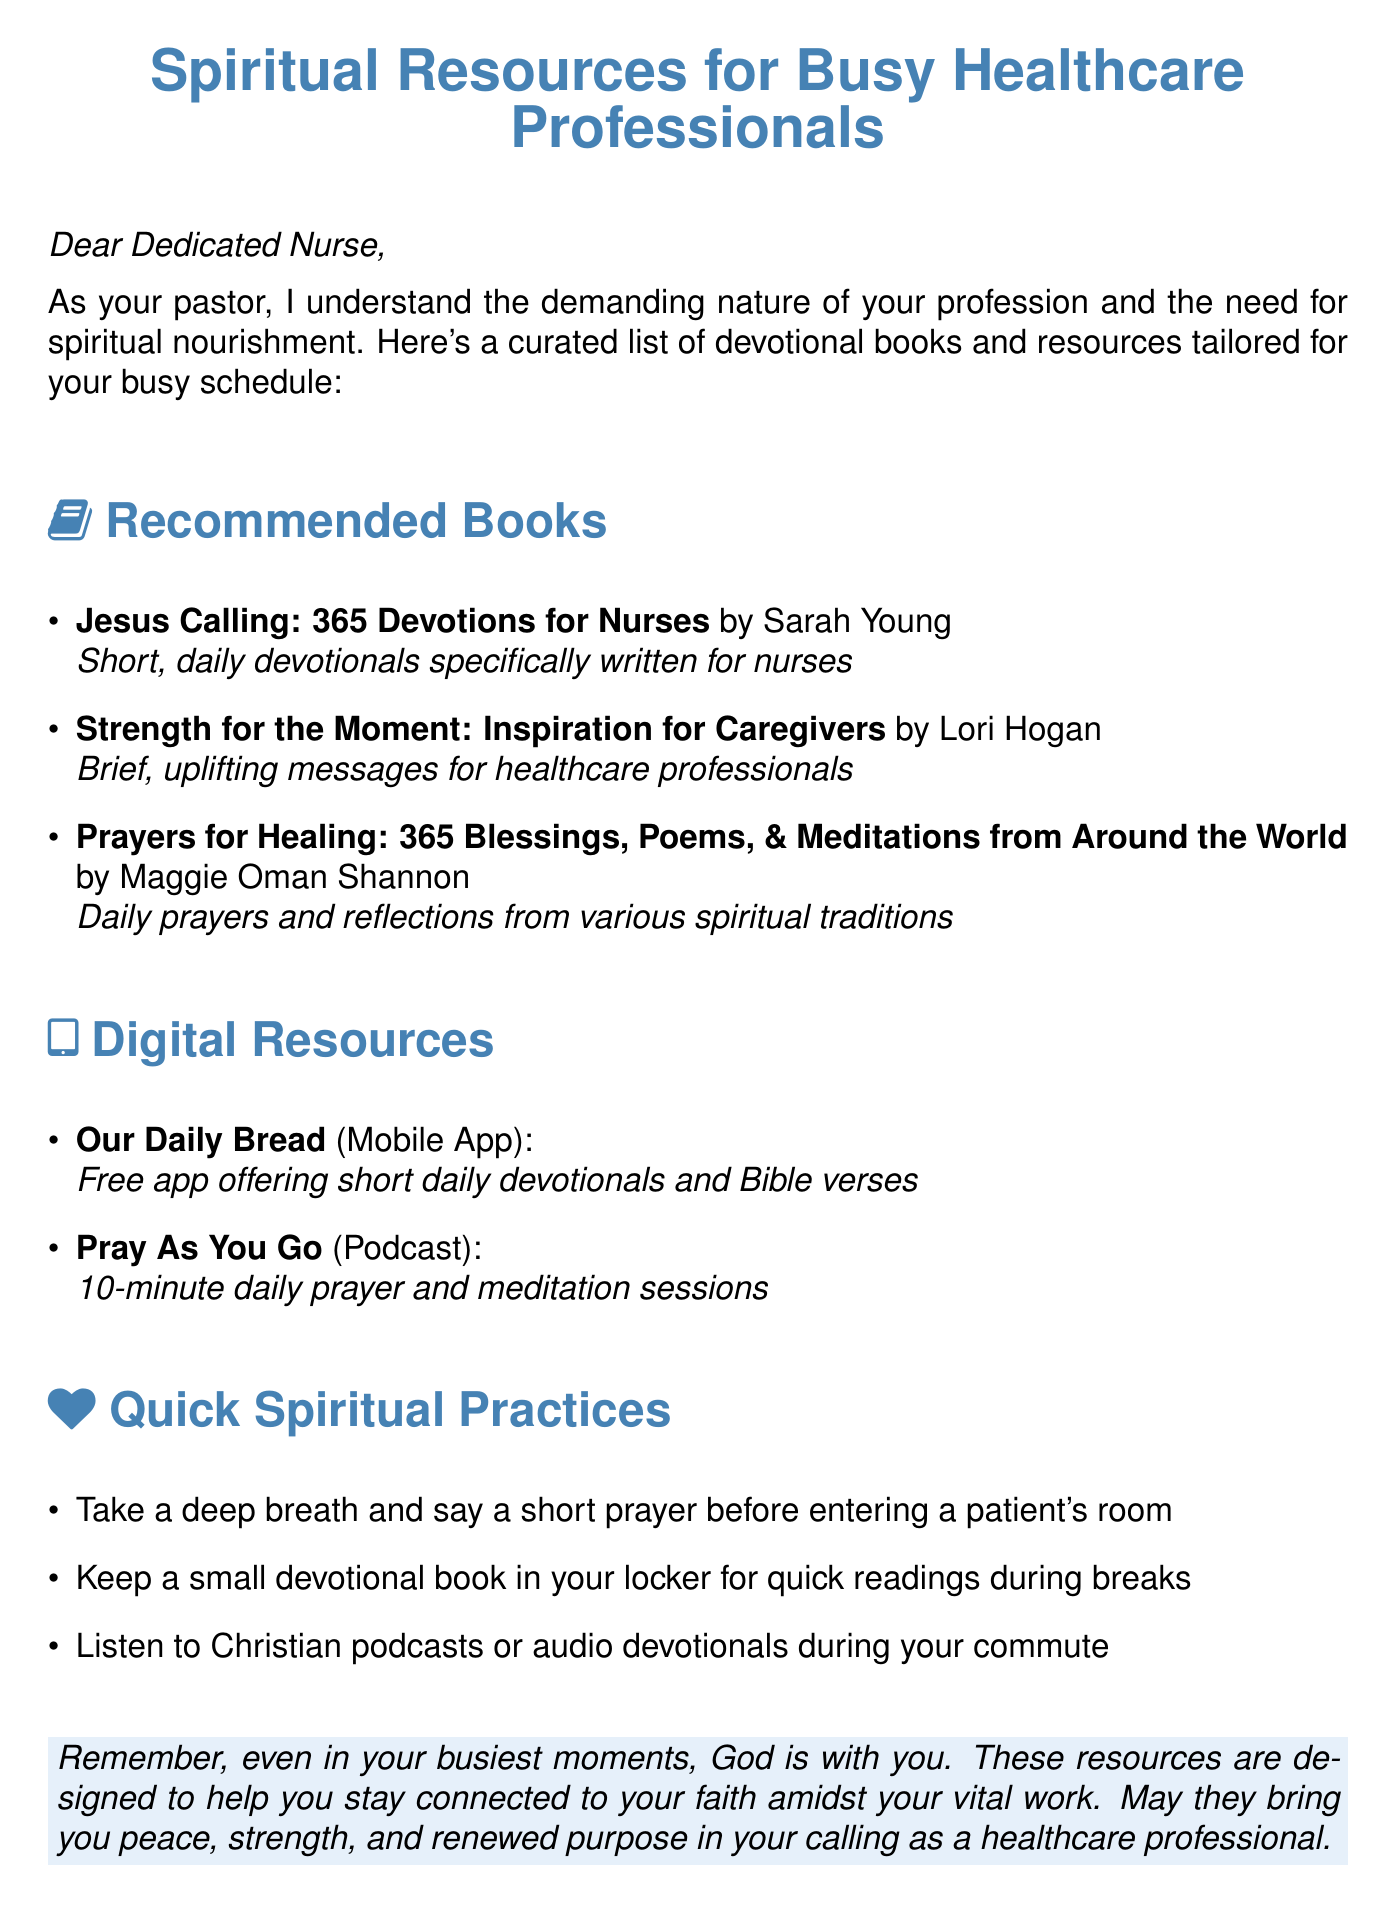What is the title of the document? The title is found at the top of the document and indicates the subject matter addressed to healthcare professionals.
Answer: Spiritual Resources for Busy Healthcare Professionals Who is the author of "Jesus Calling"? This question asks for the author of a specific recommended book listed in the document.
Answer: Sarah Young What type of resources are included in the document? This looks for the categories of resources recommended for healthcare professionals as specified in the sections.
Answer: Books and Digital Resources How many daily devotionals are included in "Jesus Calling"? This question references the structure of the book mentioned in the document for nurses.
Answer: 365 What is one quick spiritual practice suggested for nurses? This asks for an example of a quick spiritual practice mentioned in the document.
Answer: Take a deep breath and say a short prayer before entering a patient's room What digital resource is available as a mobile app? This question specifically requests the name of a digital resource that is offered in app form.
Answer: Our Daily Bread Which author wrote "Strength for the Moment"? This question seeks the author of a specific book listed under the recommended books section.
Answer: Lori Hogan What type of content does "Pray As You Go" provide? This question seeks to clarify the nature of the digital resource "Pray As You Go" mentioned in the document.
Answer: Podcast What color is used for section headings? This looks for the design choice made in the document for the section headings.
Answer: Pastor blue 